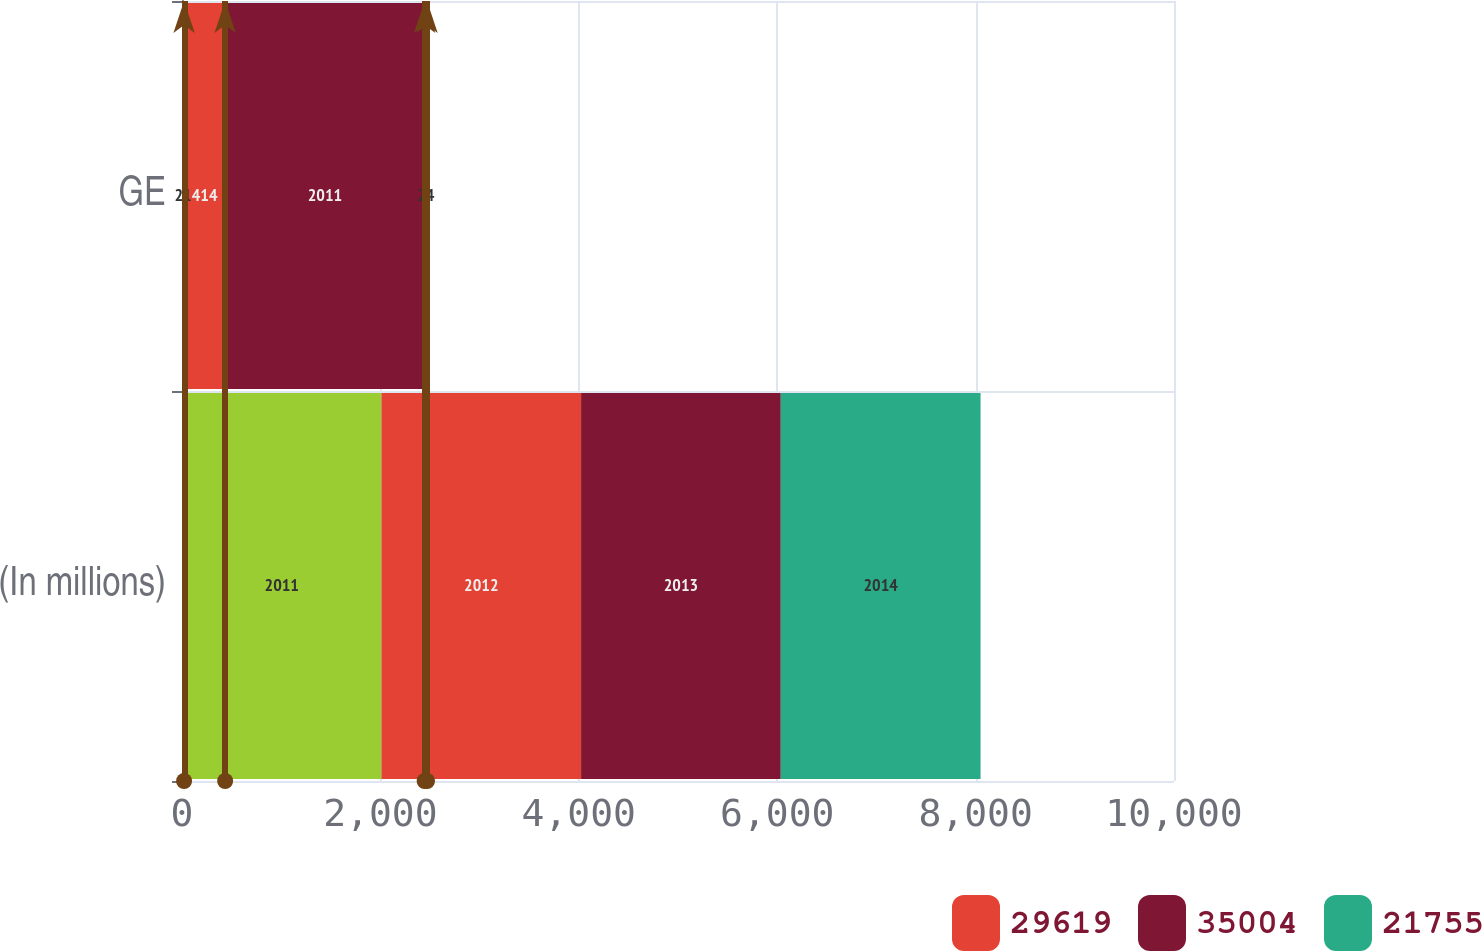Convert chart to OTSL. <chart><loc_0><loc_0><loc_500><loc_500><stacked_bar_chart><ecel><fcel>(In millions)<fcel>GE<nl><fcel>nan<fcel>2011<fcel>21<nl><fcel>29619<fcel>2012<fcel>414<nl><fcel>35004<fcel>2013<fcel>2011<nl><fcel>21755<fcel>2014<fcel>24<nl></chart> 